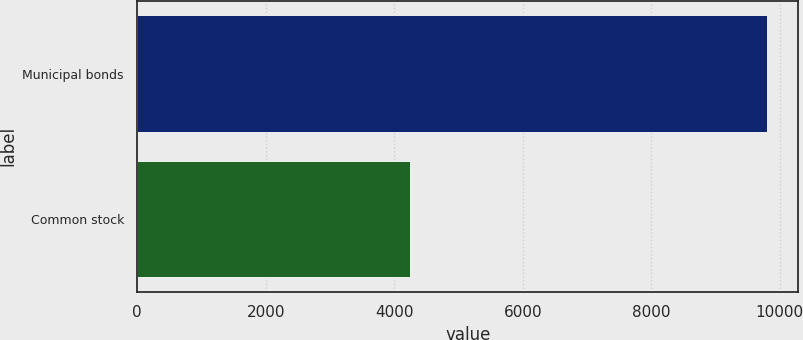Convert chart to OTSL. <chart><loc_0><loc_0><loc_500><loc_500><bar_chart><fcel>Municipal bonds<fcel>Common stock<nl><fcel>9797<fcel>4250<nl></chart> 